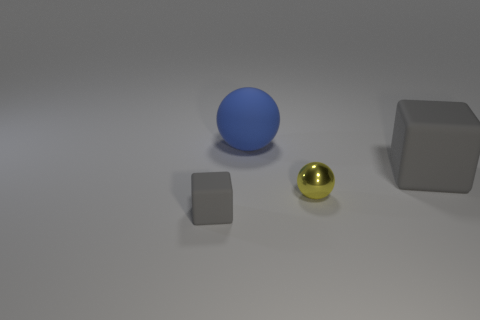The metal sphere has what size?
Offer a terse response. Small. There is a tiny object behind the gray matte cube left of the metallic thing; is there a gray thing that is behind it?
Your answer should be compact. Yes. There is a tiny gray rubber object; what number of rubber spheres are in front of it?
Offer a very short reply. 0. What number of large rubber things are the same color as the tiny rubber thing?
Provide a succinct answer. 1. How many things are either rubber things left of the metallic ball or cubes that are on the right side of the blue matte ball?
Offer a very short reply. 3. Are there more tiny gray rubber things than tiny brown balls?
Give a very brief answer. Yes. What color is the rubber object that is left of the blue rubber object?
Your answer should be very brief. Gray. Is the shape of the yellow shiny thing the same as the blue rubber object?
Offer a very short reply. Yes. There is a matte object that is both in front of the large blue matte ball and to the right of the small matte cube; what color is it?
Offer a very short reply. Gray. Is the size of the gray matte object that is right of the tiny gray rubber thing the same as the blue matte object that is to the right of the tiny matte block?
Your answer should be very brief. Yes. 